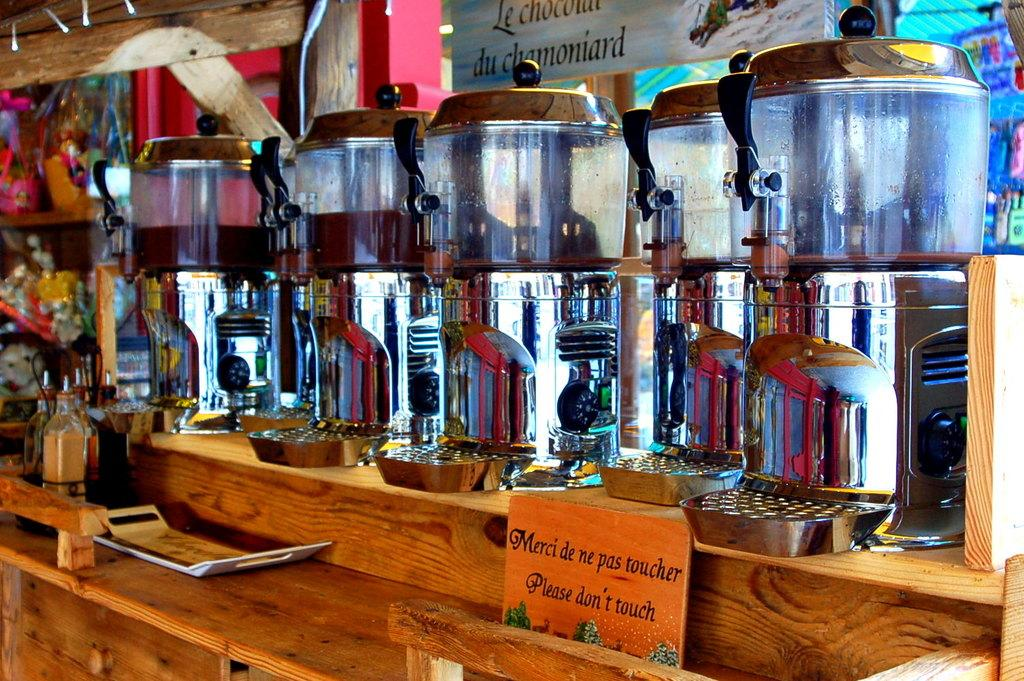Provide a one-sentence caption for the provided image. A sign on the counter asks, "Please don't touch". 